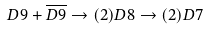Convert formula to latex. <formula><loc_0><loc_0><loc_500><loc_500>D 9 + \overline { D 9 } \rightarrow ( 2 ) { D 8 } \rightarrow ( 2 ) D 7</formula> 